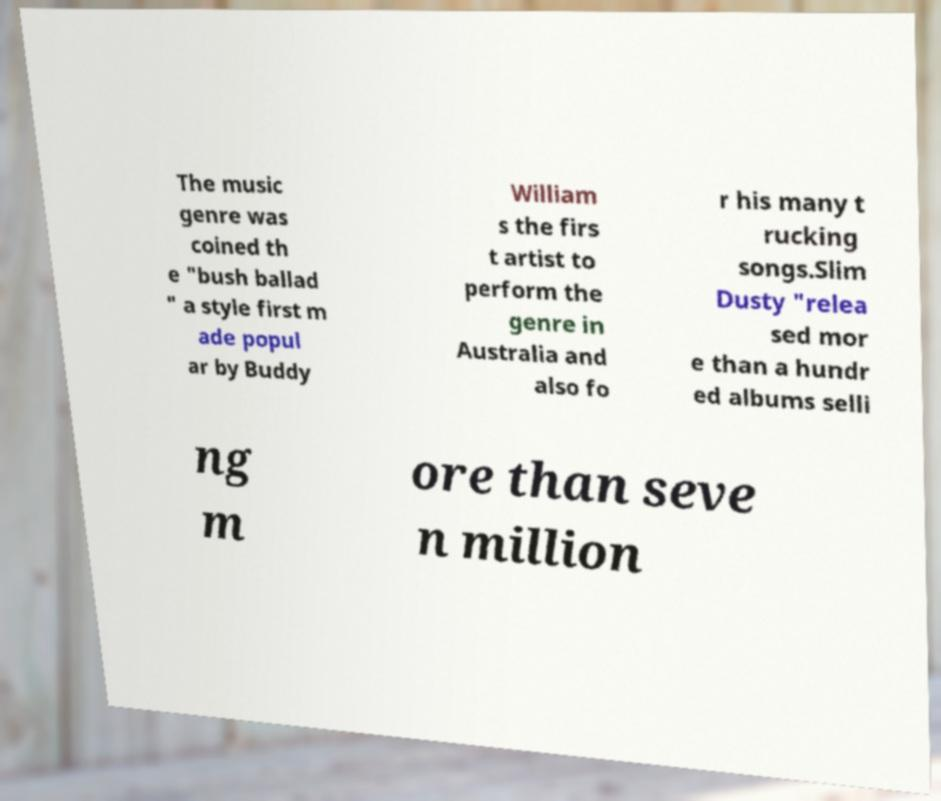For documentation purposes, I need the text within this image transcribed. Could you provide that? The music genre was coined th e "bush ballad " a style first m ade popul ar by Buddy William s the firs t artist to perform the genre in Australia and also fo r his many t rucking songs.Slim Dusty "relea sed mor e than a hundr ed albums selli ng m ore than seve n million 